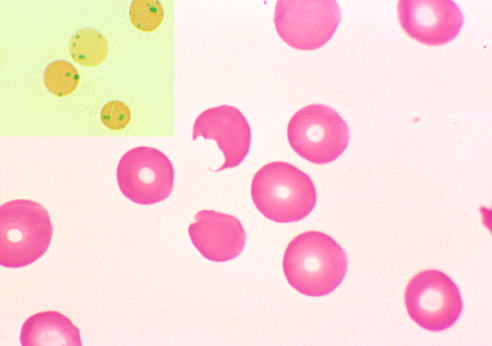do the segregation of b cells and t cells in different regions of the lymph node pluck out these inclusions?
Answer the question using a single word or phrase. No 